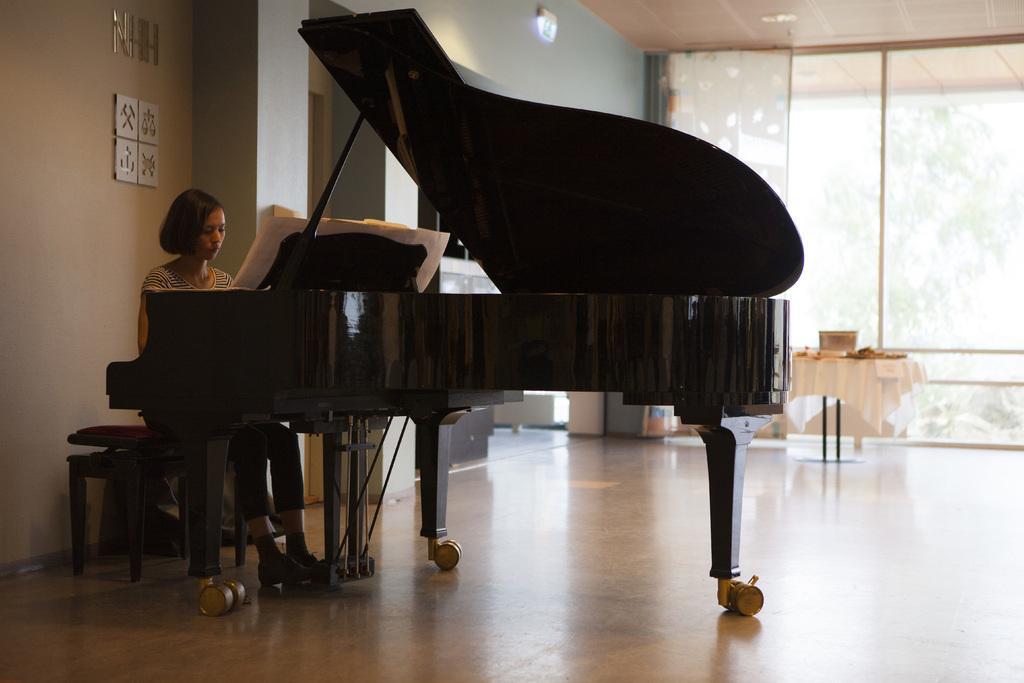Please provide a concise description of this image. There is a girl sitting in front of a piano in the foreground area of the image, there are glass windows, trees, table and other objects in the background. 